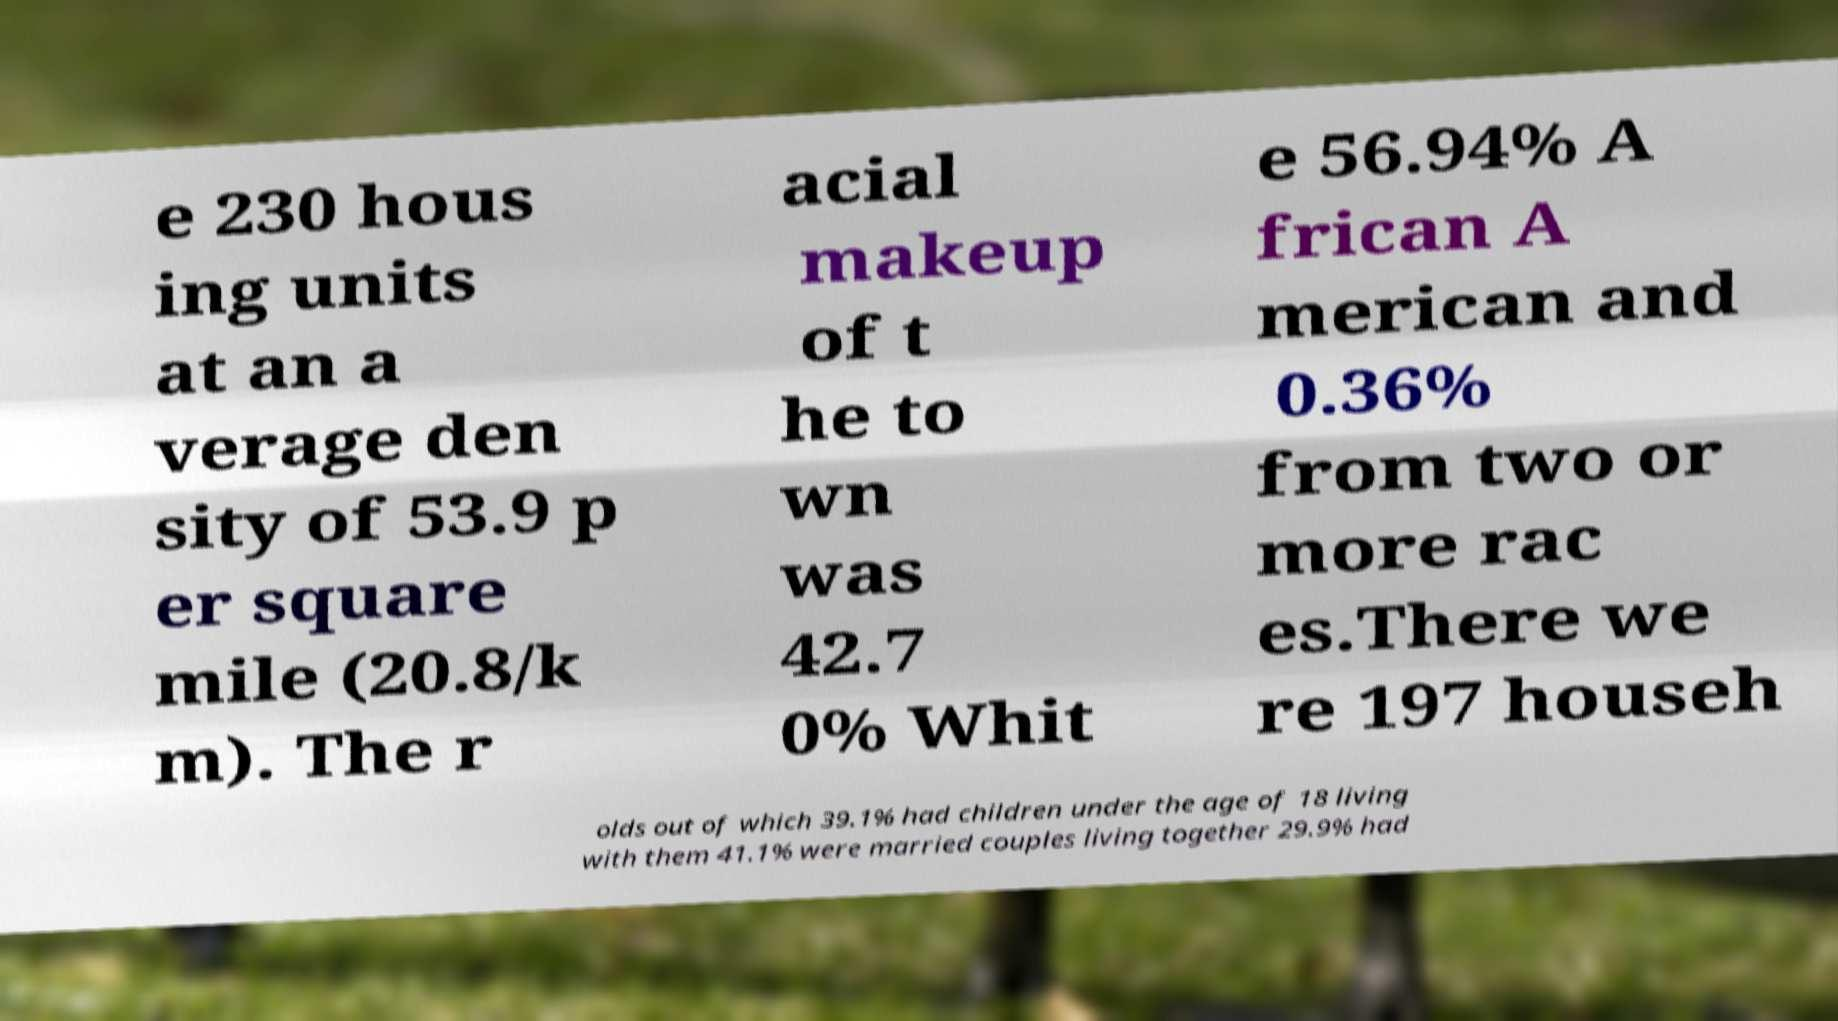Can you read and provide the text displayed in the image?This photo seems to have some interesting text. Can you extract and type it out for me? e 230 hous ing units at an a verage den sity of 53.9 p er square mile (20.8/k m). The r acial makeup of t he to wn was 42.7 0% Whit e 56.94% A frican A merican and 0.36% from two or more rac es.There we re 197 househ olds out of which 39.1% had children under the age of 18 living with them 41.1% were married couples living together 29.9% had 